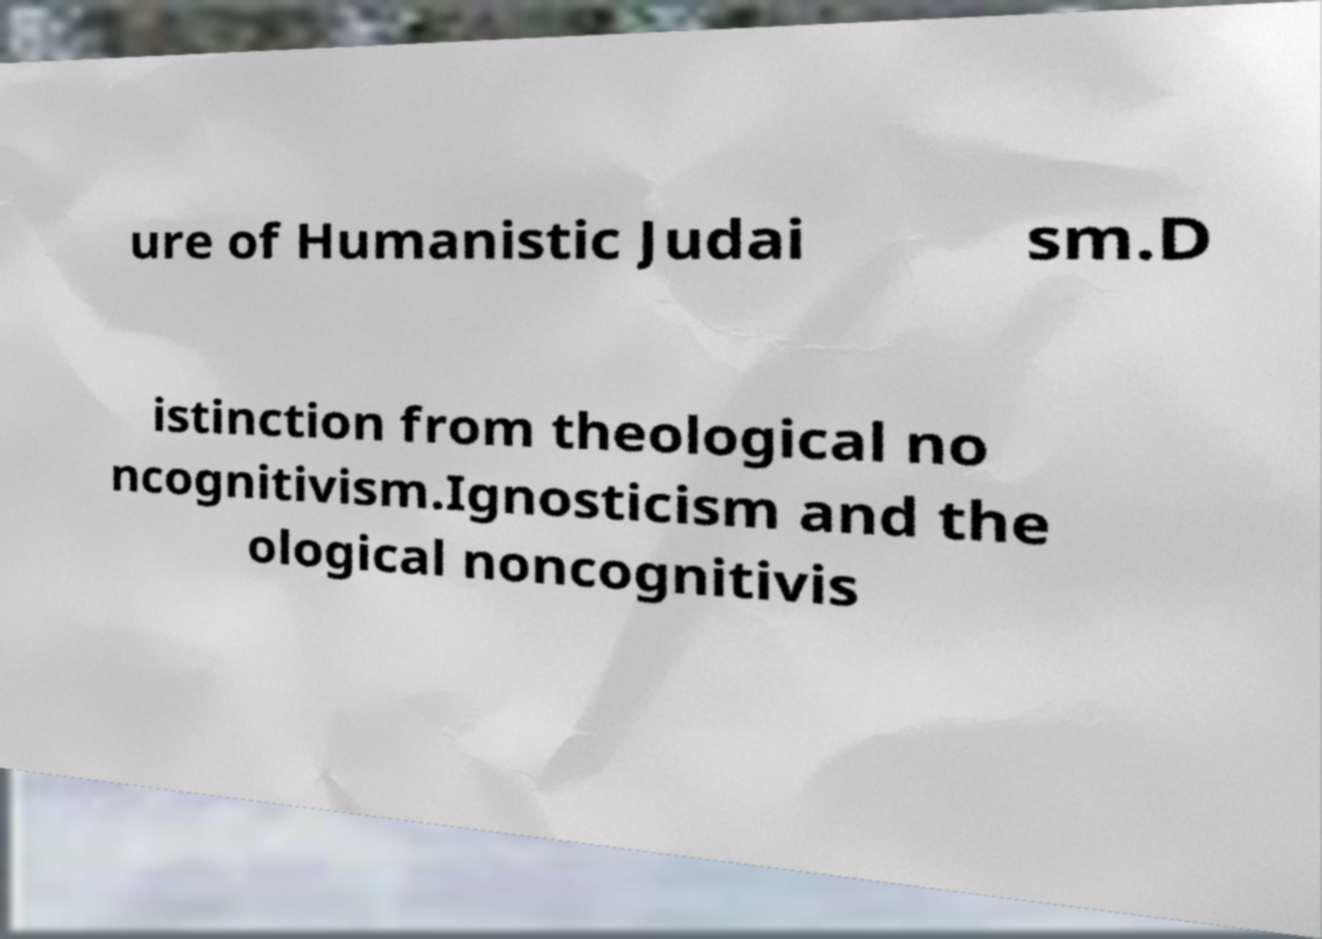I need the written content from this picture converted into text. Can you do that? ure of Humanistic Judai sm.D istinction from theological no ncognitivism.Ignosticism and the ological noncognitivis 